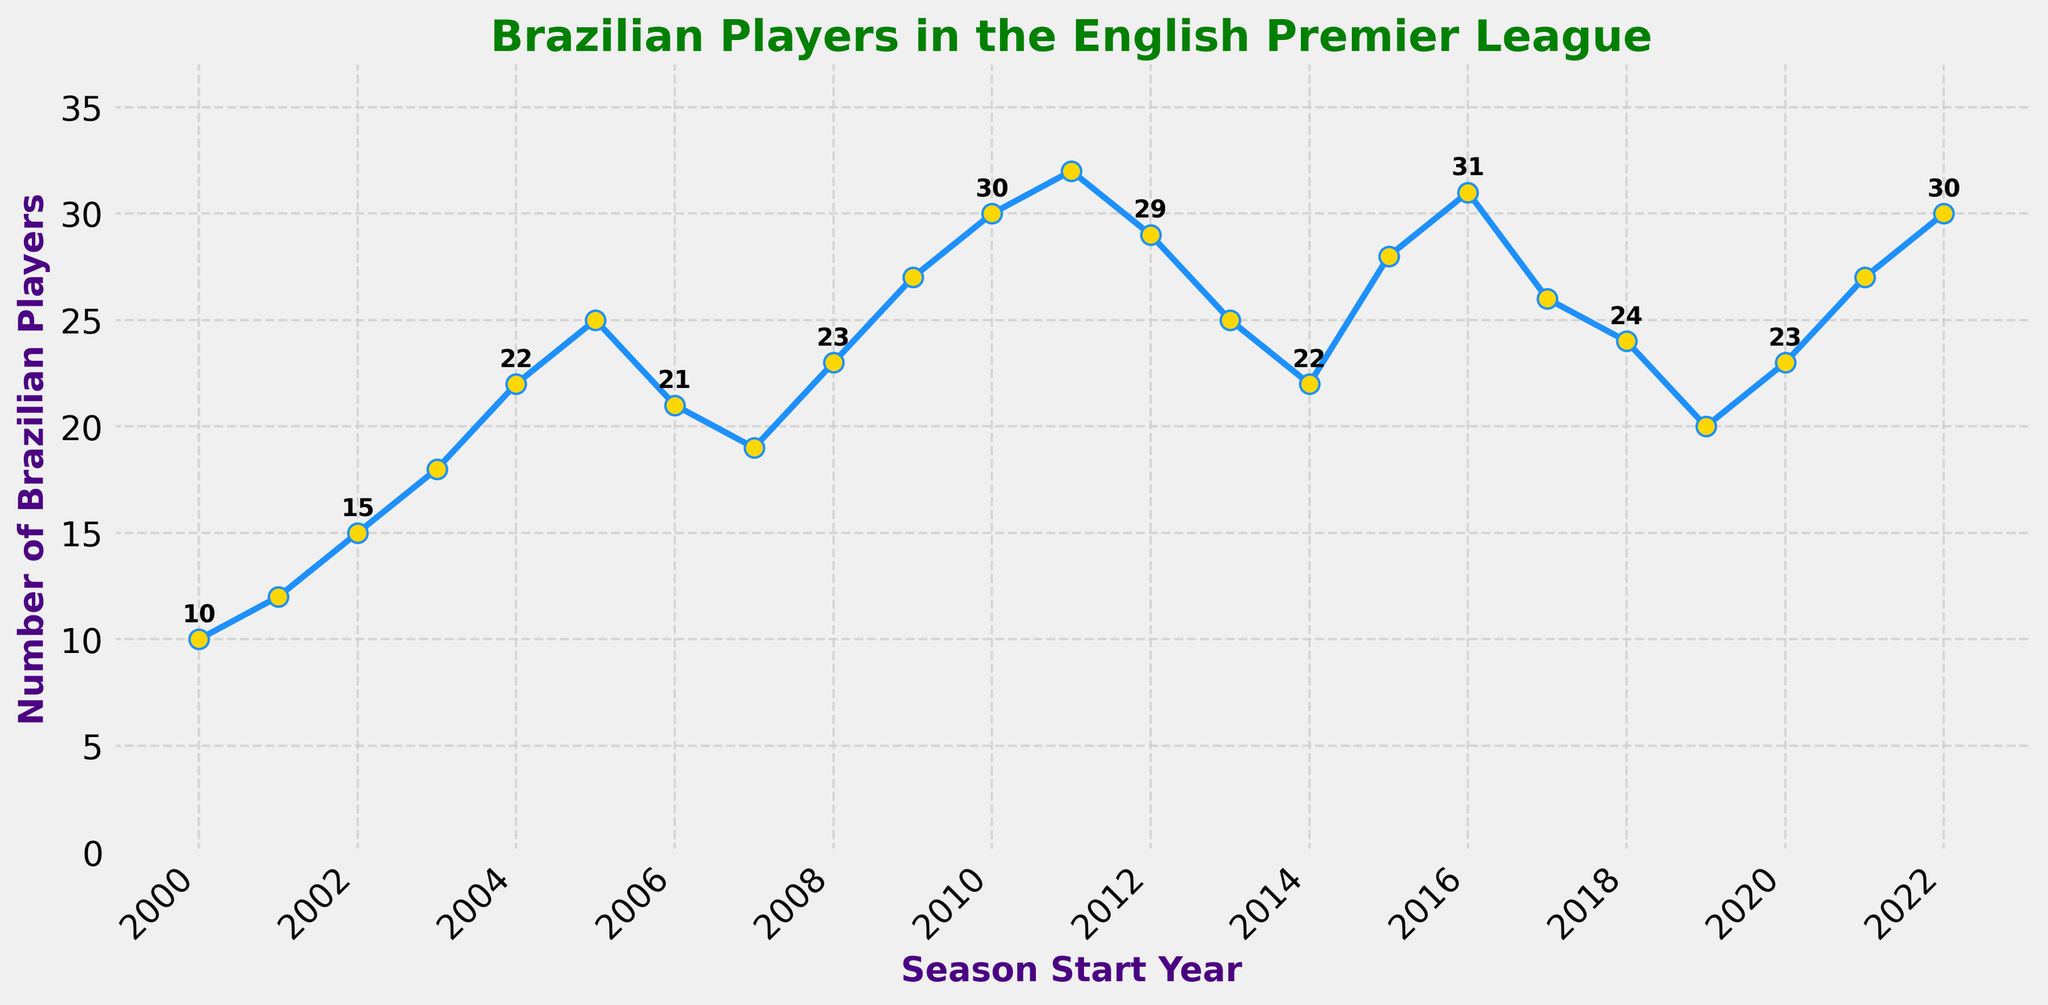What's the highest number of Brazilian players in the English Premier League and in which season did it occur? To find the highest number, look at the topmost point on the line chart. This peak occurs at the value 32, which corresponds to the 2011-12 season.
Answer: 32, 2011-12 season Which season saw the lowest number of Brazilian players in the Premier League between 2000 and 2023? Find the lowest point on the chart. The minimum value is 10, which happens during the 2000-01 season.
Answer: 2000-01 season By how much did the number of Brazilian players increase from the 2000-01 season to the 2004-05 season? Subtract the number of players in the 2000-01 season (10) from the number in the 2004-05 season (22). So, 22 - 10 = 12.
Answer: 12 players Which seasons have a higher number of Brazilian players: 2010-11 or 2013-14? Look at the values for the 2010-11 and 2013-14 seasons. The 2010-11 season has 30, and the 2013-14 season has 25.
Answer: 2010-11 season How many seasons saw a decrease in the number of Brazilian players compared to the previous season? Identify the seasons where the line goes downward. These are: 2006-07, 2007-08, 2012-13, 2013-14, 2014-15, 2017-18, 2018-19, 2019-20. Count them.
Answer: 8 seasons What is the average number of Brazilian players over the given period? Add all the values and then divide by the number of seasons. (10 + 12 + 15 + 18 + 22 + 25 + 21 + 19 + 23 + 27 + 30 + 32 + 29 + 25 + 22 + 28 + 31 + 26 + 24 + 20 + 23 + 27 + 30) / 23 = 23.91.
Answer: ~24 players During which periods does the trend show the most consistent growth in the number of Brazilian players? Identify periods where the line consistently goes up. The period from 2000-01 to 2005-06 shows steady growth.
Answer: 2000-01 to 2005-06 Which year saw a significant drop in the number of players after maintaining a steady high for a few seasons? Identify fluctuations after a period of increase. The drop from 2011-12 (32) to 2012-13 (29) is significant after a steady high.
Answer: 2012-13 How does the number of Brazilian players in the 2022-23 season compare with the earliest season in the data? Compare the values for 2022-23 (30) and 2000-01 (10). 30 is significantly higher than 10.
Answer: 2022-23 is higher During which seasons did the number of Brazilian players oscillate frequently between rises and falls? Observe periods with frequent ups and downs. The period from 2015-16 to 2019-20 shows fluctuating numbers.
Answer: 2015-16 to 2019-20 